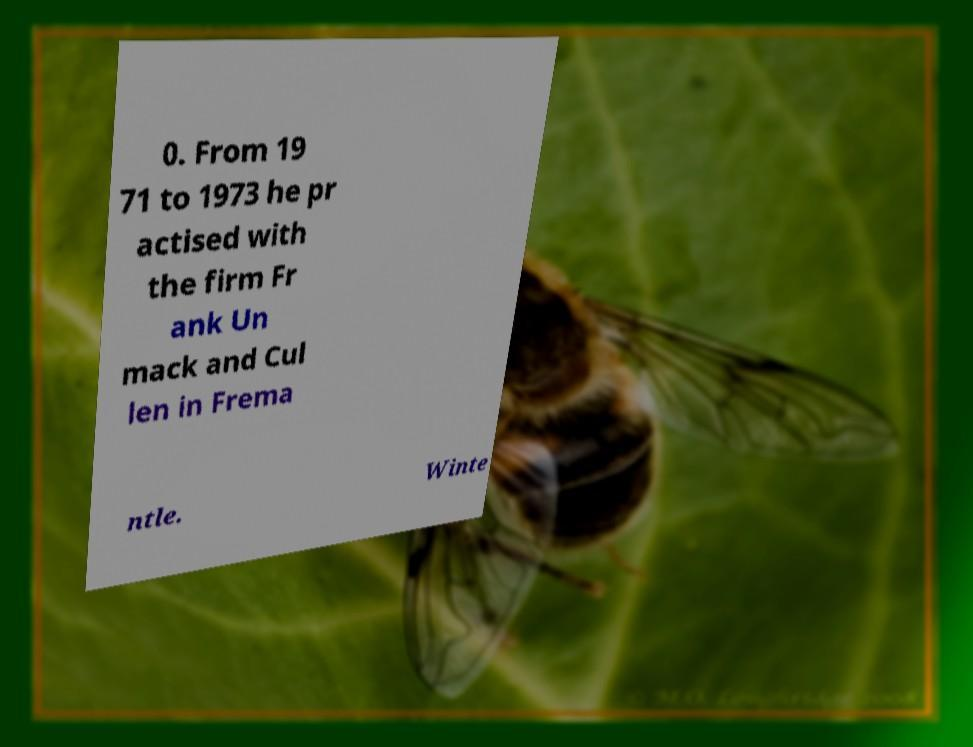Could you assist in decoding the text presented in this image and type it out clearly? 0. From 19 71 to 1973 he pr actised with the firm Fr ank Un mack and Cul len in Frema ntle. Winte 